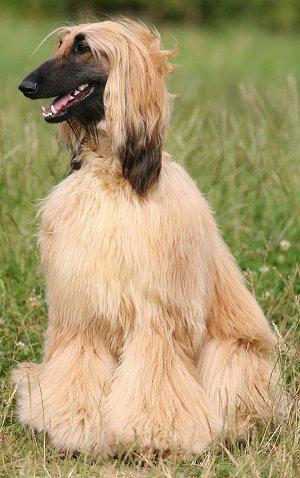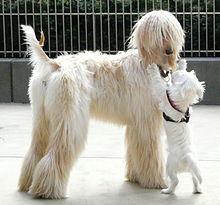The first image is the image on the left, the second image is the image on the right. Given the left and right images, does the statement "There are no less than three dogs" hold true? Answer yes or no. Yes. The first image is the image on the left, the second image is the image on the right. Analyze the images presented: Is the assertion "Both dogs are facing the same direction." valid? Answer yes or no. No. The first image is the image on the left, the second image is the image on the right. Evaluate the accuracy of this statement regarding the images: "Only the left image shows a dog on a grassy area.". Is it true? Answer yes or no. Yes. 